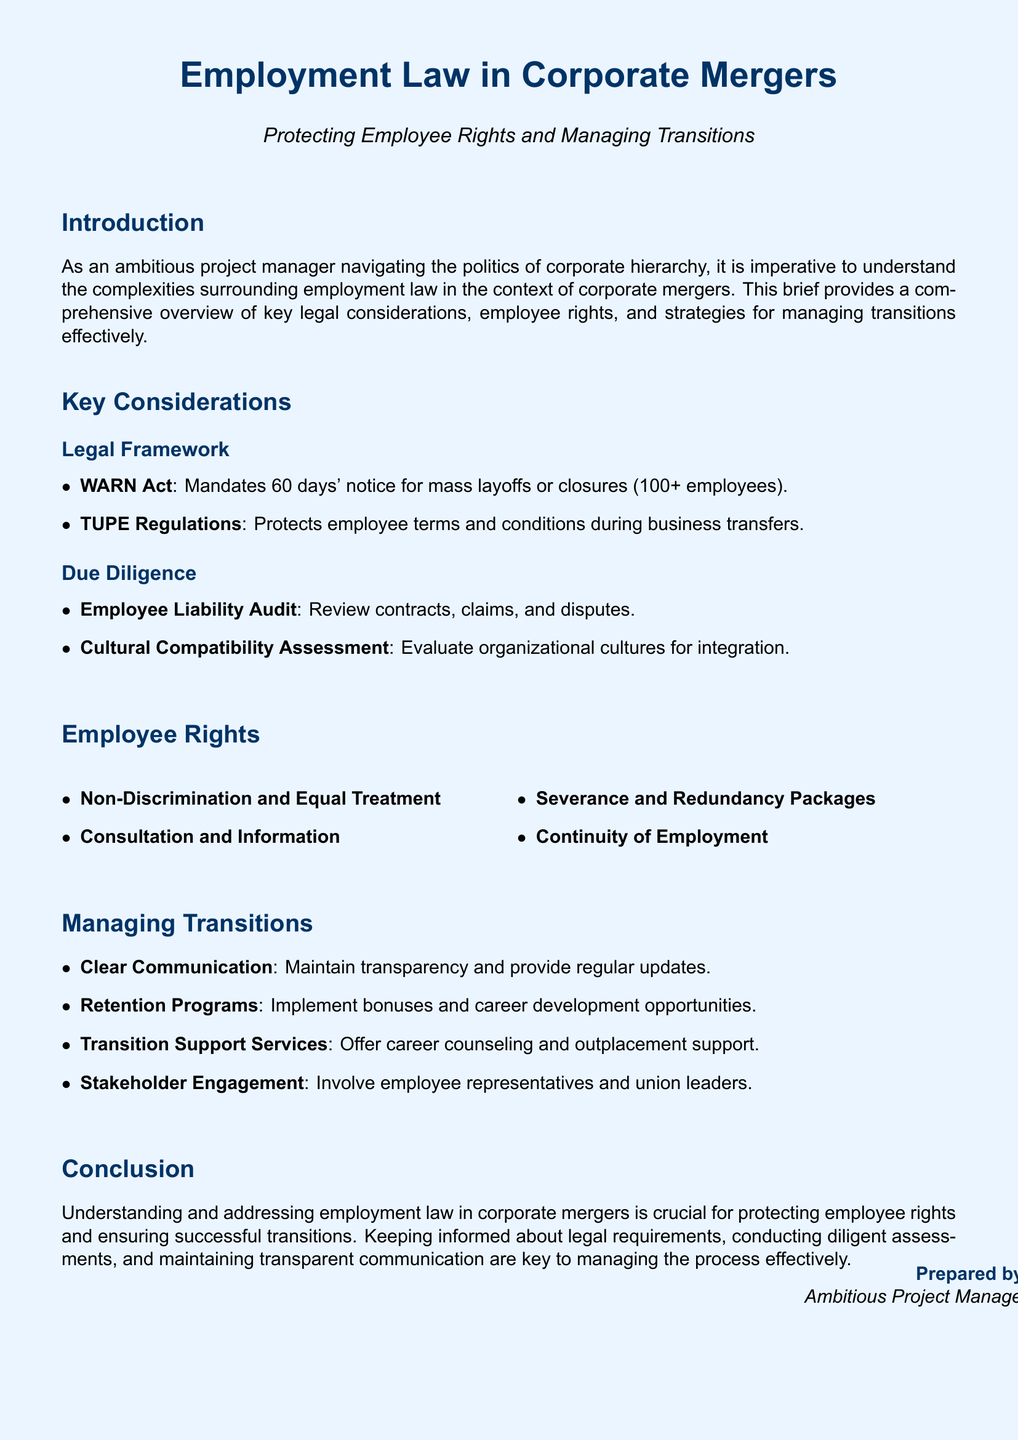what is the primary focus of the document? The document provides an overview of employment law in the context of corporate mergers, specifically focusing on employee rights and transitions.
Answer: Employment law in corporate mergers what does the WARN Act require? The WARN Act mandates that employers provide 60 days' notice for mass layoffs or closures involving 100 or more employees.
Answer: 60 days' notice what should be included in an Employee Liability Audit? An Employee Liability Audit should include a review of contracts, claims, and disputes related to employees.
Answer: Review contracts, claims, and disputes name one of the employee rights listed in the document. The document lists several employee rights, one of which is consultation and information.
Answer: Consultation and Information what is a recommended strategy for managing transitions? The document recommends maintaining clear communication as a strategy for managing transitions during corporate mergers.
Answer: Clear Communication which regulation protects employee terms during business transfers? TUPE Regulations are designed to protect employee terms and conditions during business transfers.
Answer: TUPE Regulations what type of support is suggested to help employees during transitions? Transition Support Services such as career counseling and outplacement support are suggested to help employees.
Answer: Career counseling and outplacement support who should be involved in stakeholder engagement during transitions? Employee representatives and union leaders should be involved in stakeholder engagement.
Answer: Employee representatives and union leaders what is a key element in the conclusion of the document? The conclusion emphasizes the importance of understanding employment law to protect employee rights during mergers.
Answer: Protecting employee rights 